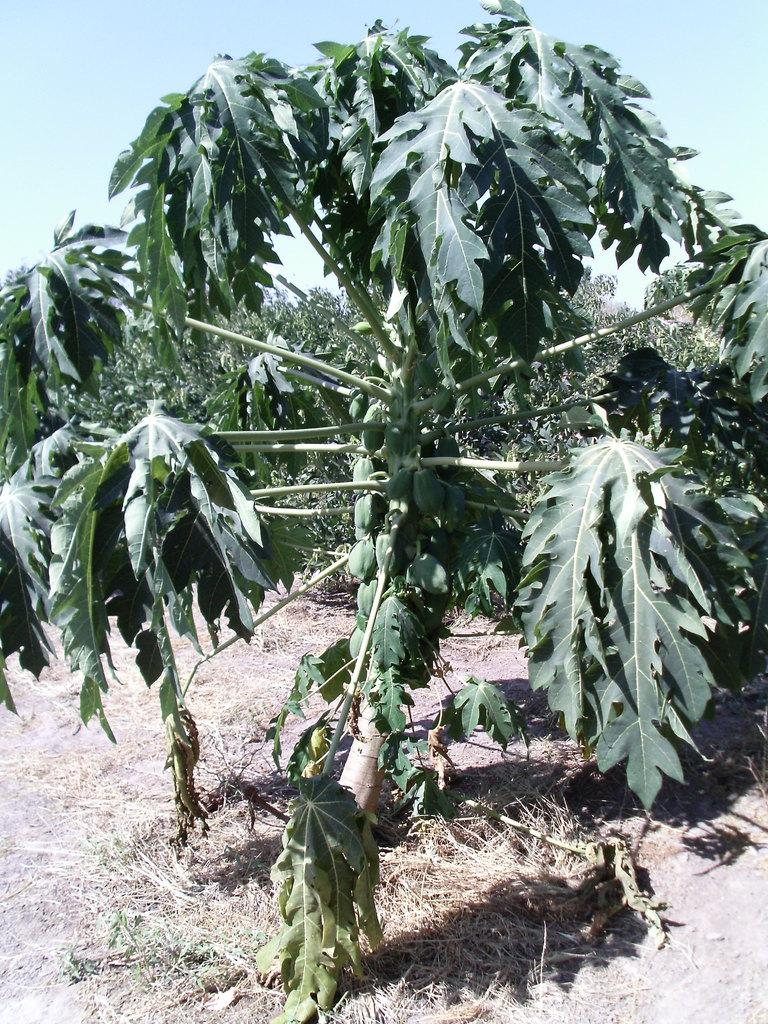What type of vegetation can be seen in the image? There is a plant in the image, and there are plants and trees in the background. What is the condition of the ground in the image? Dry grass is present on the ground. What is visible at the top of the image? The sky is visible at the top of the image. What type of organization is depicted in the image? There is no organization depicted in the image; it features a plant, dry grass, and the sky. Can you see any cobwebs in the image? There are no cobwebs present in the image. 